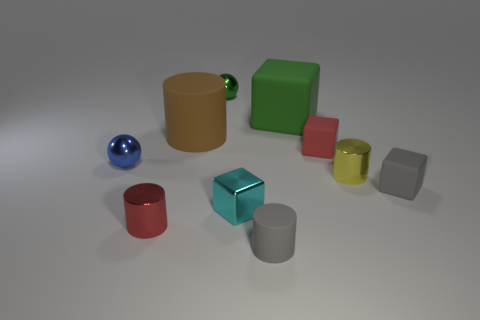Compare the size of the blue sphere to the teal cube. The blue sphere is smaller than the teal cube. While the sphere has a smooth, continuous shape, the teal cube has distinct edges and faces, and occupies more space overall. 